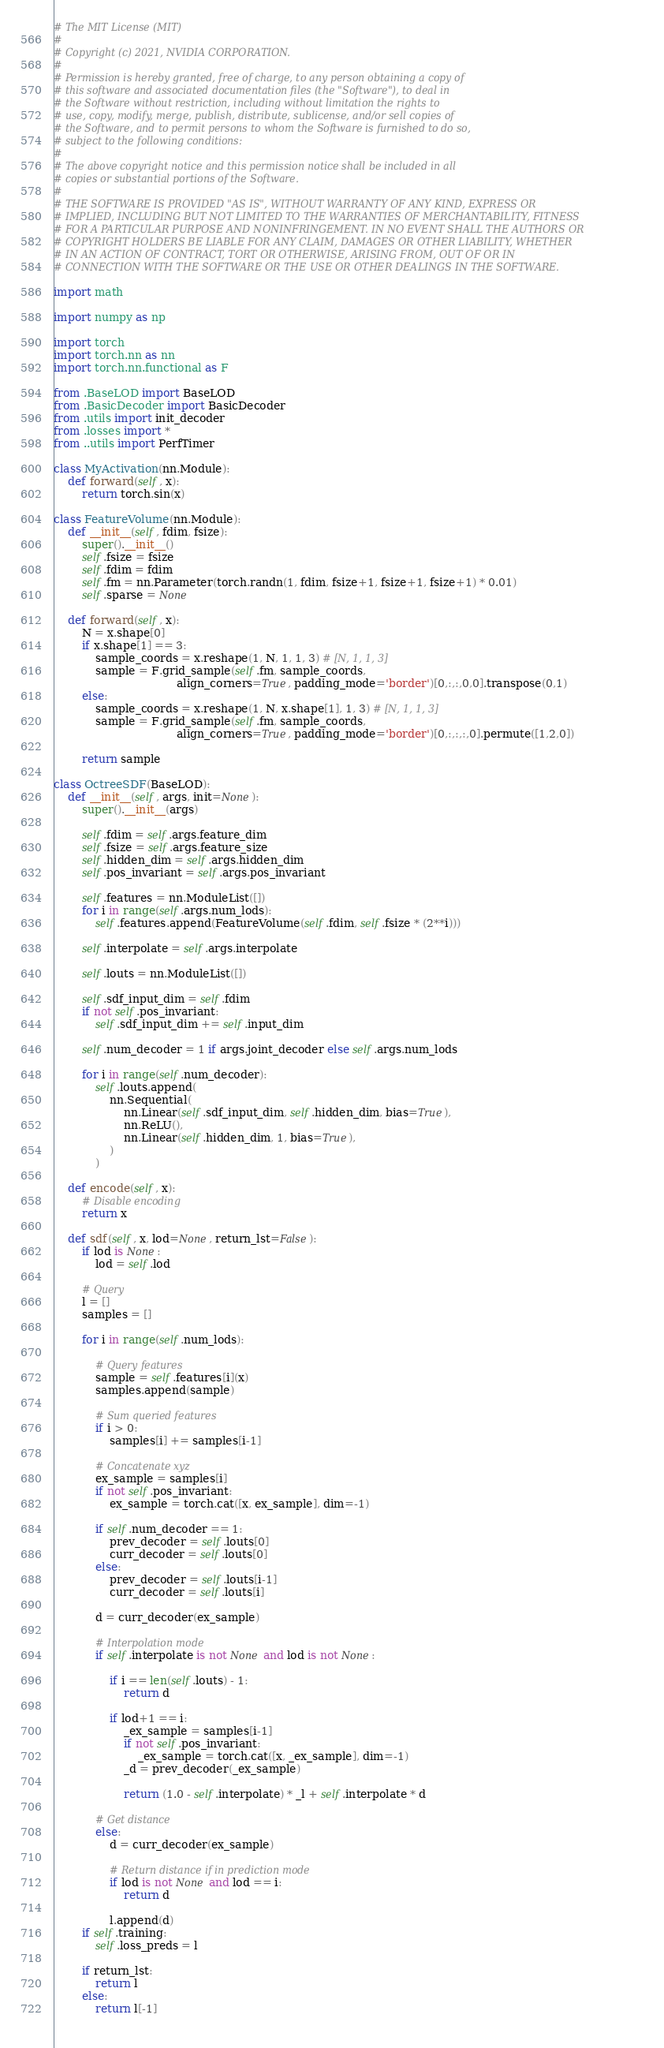<code> <loc_0><loc_0><loc_500><loc_500><_Python_># The MIT License (MIT)
#
# Copyright (c) 2021, NVIDIA CORPORATION.
#
# Permission is hereby granted, free of charge, to any person obtaining a copy of
# this software and associated documentation files (the "Software"), to deal in
# the Software without restriction, including without limitation the rights to
# use, copy, modify, merge, publish, distribute, sublicense, and/or sell copies of
# the Software, and to permit persons to whom the Software is furnished to do so,
# subject to the following conditions:
#
# The above copyright notice and this permission notice shall be included in all
# copies or substantial portions of the Software.
#
# THE SOFTWARE IS PROVIDED "AS IS", WITHOUT WARRANTY OF ANY KIND, EXPRESS OR
# IMPLIED, INCLUDING BUT NOT LIMITED TO THE WARRANTIES OF MERCHANTABILITY, FITNESS
# FOR A PARTICULAR PURPOSE AND NONINFRINGEMENT. IN NO EVENT SHALL THE AUTHORS OR
# COPYRIGHT HOLDERS BE LIABLE FOR ANY CLAIM, DAMAGES OR OTHER LIABILITY, WHETHER
# IN AN ACTION OF CONTRACT, TORT OR OTHERWISE, ARISING FROM, OUT OF OR IN
# CONNECTION WITH THE SOFTWARE OR THE USE OR OTHER DEALINGS IN THE SOFTWARE.

import math 

import numpy as np

import torch
import torch.nn as nn
import torch.nn.functional as F

from .BaseLOD import BaseLOD
from .BasicDecoder import BasicDecoder
from .utils import init_decoder
from .losses import *
from ..utils import PerfTimer

class MyActivation(nn.Module):
    def forward(self, x):
        return torch.sin(x)

class FeatureVolume(nn.Module):
    def __init__(self, fdim, fsize):
        super().__init__()
        self.fsize = fsize
        self.fdim = fdim
        self.fm = nn.Parameter(torch.randn(1, fdim, fsize+1, fsize+1, fsize+1) * 0.01)
        self.sparse = None

    def forward(self, x):
        N = x.shape[0]
        if x.shape[1] == 3:
            sample_coords = x.reshape(1, N, 1, 1, 3) # [N, 1, 1, 3]    
            sample = F.grid_sample(self.fm, sample_coords, 
                                   align_corners=True, padding_mode='border')[0,:,:,0,0].transpose(0,1)
        else:
            sample_coords = x.reshape(1, N, x.shape[1], 1, 3) # [N, 1, 1, 3]    
            sample = F.grid_sample(self.fm, sample_coords, 
                                   align_corners=True, padding_mode='border')[0,:,:,:,0].permute([1,2,0])
        
        return sample

class OctreeSDF(BaseLOD):
    def __init__(self, args, init=None):
        super().__init__(args)

        self.fdim = self.args.feature_dim
        self.fsize = self.args.feature_size
        self.hidden_dim = self.args.hidden_dim
        self.pos_invariant = self.args.pos_invariant

        self.features = nn.ModuleList([])
        for i in range(self.args.num_lods):
            self.features.append(FeatureVolume(self.fdim, self.fsize * (2**i)))
    
        self.interpolate = self.args.interpolate

        self.louts = nn.ModuleList([])

        self.sdf_input_dim = self.fdim
        if not self.pos_invariant:
            self.sdf_input_dim += self.input_dim

        self.num_decoder = 1 if args.joint_decoder else self.args.num_lods 

        for i in range(self.num_decoder):
            self.louts.append(
                nn.Sequential(
                    nn.Linear(self.sdf_input_dim, self.hidden_dim, bias=True),
                    nn.ReLU(),
                    nn.Linear(self.hidden_dim, 1, bias=True),
                )
            )
        
    def encode(self, x):
        # Disable encoding
        return x

    def sdf(self, x, lod=None, return_lst=False):
        if lod is None:
            lod = self.lod
        
        # Query
        l = []
        samples = []

        for i in range(self.num_lods):
            
            # Query features
            sample = self.features[i](x)
            samples.append(sample)
            
            # Sum queried features
            if i > 0:
                samples[i] += samples[i-1]
            
            # Concatenate xyz
            ex_sample = samples[i]
            if not self.pos_invariant:
                ex_sample = torch.cat([x, ex_sample], dim=-1)

            if self.num_decoder == 1:
                prev_decoder = self.louts[0]
                curr_decoder = self.louts[0]
            else:
                prev_decoder = self.louts[i-1]
                curr_decoder = self.louts[i]
            
            d = curr_decoder(ex_sample)

            # Interpolation mode
            if self.interpolate is not None and lod is not None:
                
                if i == len(self.louts) - 1:
                    return d

                if lod+1 == i:
                    _ex_sample = samples[i-1]
                    if not self.pos_invariant:
                        _ex_sample = torch.cat([x, _ex_sample], dim=-1)
                    _d = prev_decoder(_ex_sample)

                    return (1.0 - self.interpolate) * _l + self.interpolate * d
            
            # Get distance
            else: 
                d = curr_decoder(ex_sample)

                # Return distance if in prediction mode
                if lod is not None and lod == i:
                    return d

                l.append(d)
        if self.training:
            self.loss_preds = l

        if return_lst:
            return l
        else:
            return l[-1]
    
</code> 